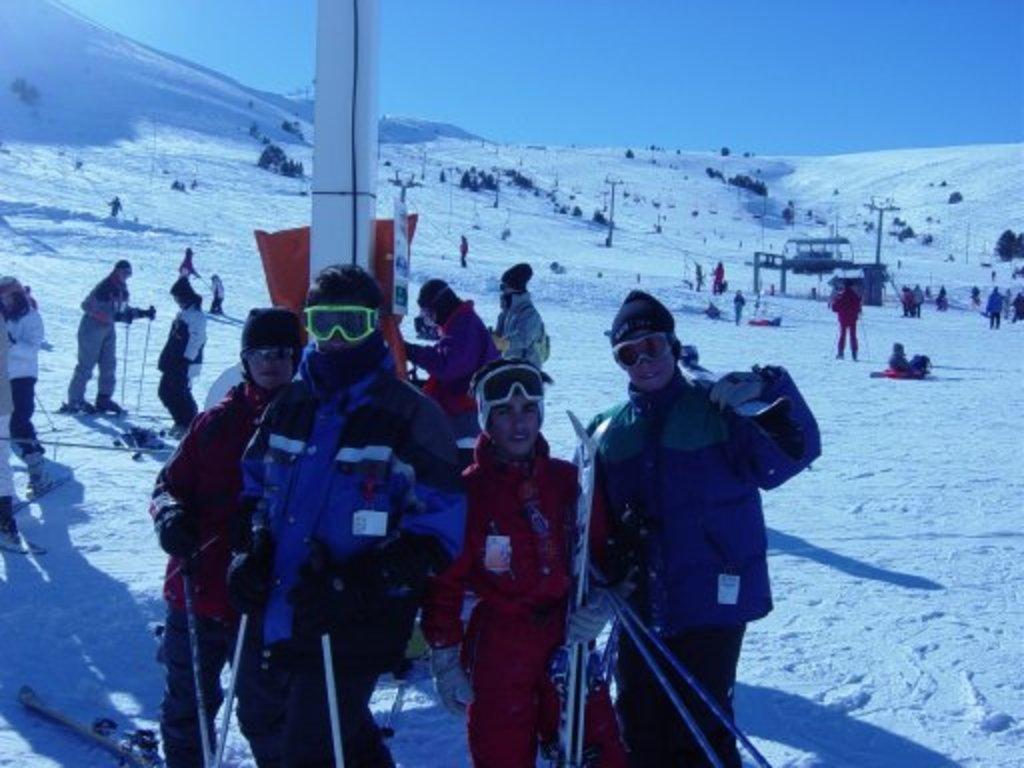Could you give a brief overview of what you see in this image? In this picture there is a man who is wearing goggles, jacket, gloves and he is holding the sticks. Here we can see group of person standing near to the pole. In the we can see poles and wires are connected to it. Here we can see trees and plants on the mountain. Here we can see snow. On the right there is a man who is sitting on the cloth. Here we can see a woman who is standing in on the snowboard. At the top there is a sky. 